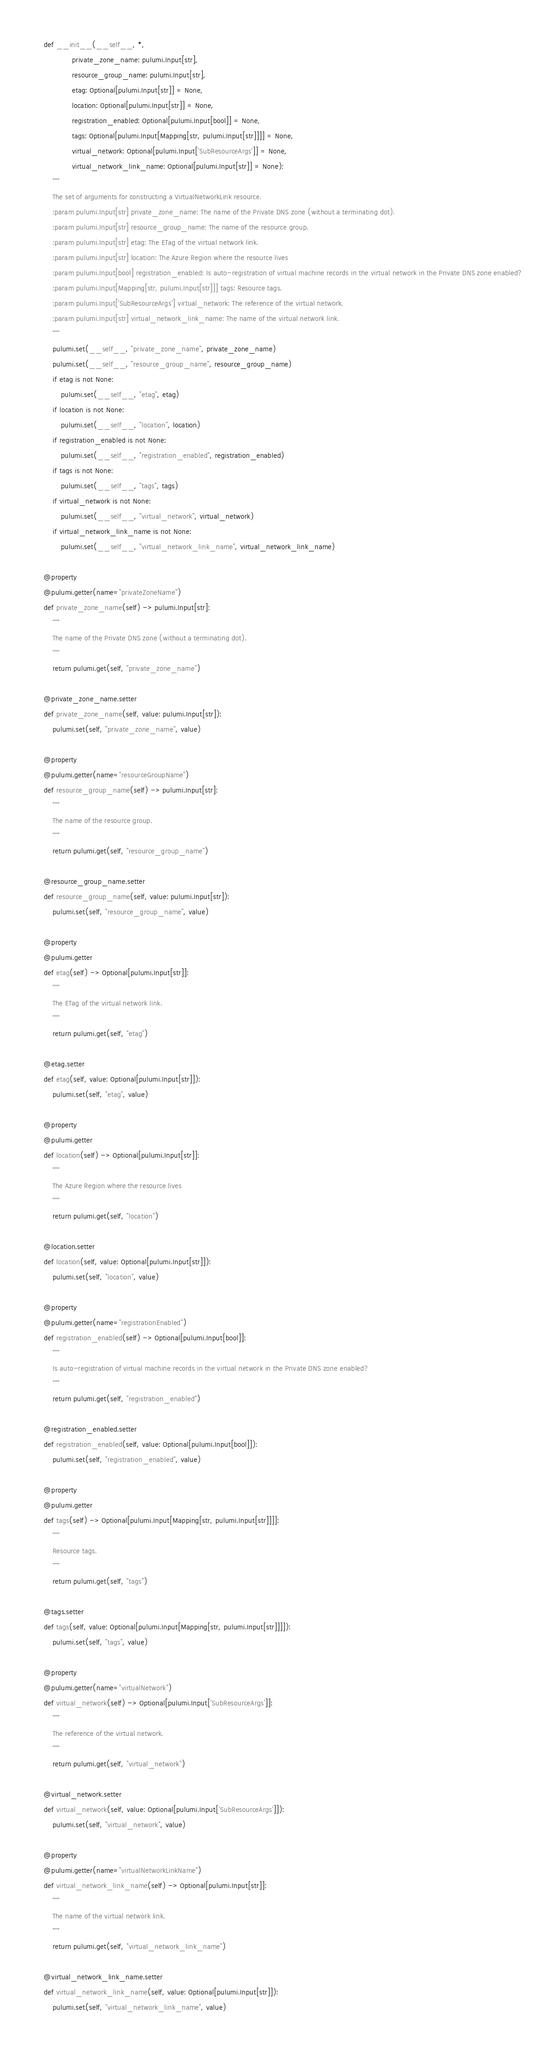Convert code to text. <code><loc_0><loc_0><loc_500><loc_500><_Python_>    def __init__(__self__, *,
                 private_zone_name: pulumi.Input[str],
                 resource_group_name: pulumi.Input[str],
                 etag: Optional[pulumi.Input[str]] = None,
                 location: Optional[pulumi.Input[str]] = None,
                 registration_enabled: Optional[pulumi.Input[bool]] = None,
                 tags: Optional[pulumi.Input[Mapping[str, pulumi.Input[str]]]] = None,
                 virtual_network: Optional[pulumi.Input['SubResourceArgs']] = None,
                 virtual_network_link_name: Optional[pulumi.Input[str]] = None):
        """
        The set of arguments for constructing a VirtualNetworkLink resource.
        :param pulumi.Input[str] private_zone_name: The name of the Private DNS zone (without a terminating dot).
        :param pulumi.Input[str] resource_group_name: The name of the resource group.
        :param pulumi.Input[str] etag: The ETag of the virtual network link.
        :param pulumi.Input[str] location: The Azure Region where the resource lives
        :param pulumi.Input[bool] registration_enabled: Is auto-registration of virtual machine records in the virtual network in the Private DNS zone enabled?
        :param pulumi.Input[Mapping[str, pulumi.Input[str]]] tags: Resource tags.
        :param pulumi.Input['SubResourceArgs'] virtual_network: The reference of the virtual network.
        :param pulumi.Input[str] virtual_network_link_name: The name of the virtual network link.
        """
        pulumi.set(__self__, "private_zone_name", private_zone_name)
        pulumi.set(__self__, "resource_group_name", resource_group_name)
        if etag is not None:
            pulumi.set(__self__, "etag", etag)
        if location is not None:
            pulumi.set(__self__, "location", location)
        if registration_enabled is not None:
            pulumi.set(__self__, "registration_enabled", registration_enabled)
        if tags is not None:
            pulumi.set(__self__, "tags", tags)
        if virtual_network is not None:
            pulumi.set(__self__, "virtual_network", virtual_network)
        if virtual_network_link_name is not None:
            pulumi.set(__self__, "virtual_network_link_name", virtual_network_link_name)

    @property
    @pulumi.getter(name="privateZoneName")
    def private_zone_name(self) -> pulumi.Input[str]:
        """
        The name of the Private DNS zone (without a terminating dot).
        """
        return pulumi.get(self, "private_zone_name")

    @private_zone_name.setter
    def private_zone_name(self, value: pulumi.Input[str]):
        pulumi.set(self, "private_zone_name", value)

    @property
    @pulumi.getter(name="resourceGroupName")
    def resource_group_name(self) -> pulumi.Input[str]:
        """
        The name of the resource group.
        """
        return pulumi.get(self, "resource_group_name")

    @resource_group_name.setter
    def resource_group_name(self, value: pulumi.Input[str]):
        pulumi.set(self, "resource_group_name", value)

    @property
    @pulumi.getter
    def etag(self) -> Optional[pulumi.Input[str]]:
        """
        The ETag of the virtual network link.
        """
        return pulumi.get(self, "etag")

    @etag.setter
    def etag(self, value: Optional[pulumi.Input[str]]):
        pulumi.set(self, "etag", value)

    @property
    @pulumi.getter
    def location(self) -> Optional[pulumi.Input[str]]:
        """
        The Azure Region where the resource lives
        """
        return pulumi.get(self, "location")

    @location.setter
    def location(self, value: Optional[pulumi.Input[str]]):
        pulumi.set(self, "location", value)

    @property
    @pulumi.getter(name="registrationEnabled")
    def registration_enabled(self) -> Optional[pulumi.Input[bool]]:
        """
        Is auto-registration of virtual machine records in the virtual network in the Private DNS zone enabled?
        """
        return pulumi.get(self, "registration_enabled")

    @registration_enabled.setter
    def registration_enabled(self, value: Optional[pulumi.Input[bool]]):
        pulumi.set(self, "registration_enabled", value)

    @property
    @pulumi.getter
    def tags(self) -> Optional[pulumi.Input[Mapping[str, pulumi.Input[str]]]]:
        """
        Resource tags.
        """
        return pulumi.get(self, "tags")

    @tags.setter
    def tags(self, value: Optional[pulumi.Input[Mapping[str, pulumi.Input[str]]]]):
        pulumi.set(self, "tags", value)

    @property
    @pulumi.getter(name="virtualNetwork")
    def virtual_network(self) -> Optional[pulumi.Input['SubResourceArgs']]:
        """
        The reference of the virtual network.
        """
        return pulumi.get(self, "virtual_network")

    @virtual_network.setter
    def virtual_network(self, value: Optional[pulumi.Input['SubResourceArgs']]):
        pulumi.set(self, "virtual_network", value)

    @property
    @pulumi.getter(name="virtualNetworkLinkName")
    def virtual_network_link_name(self) -> Optional[pulumi.Input[str]]:
        """
        The name of the virtual network link.
        """
        return pulumi.get(self, "virtual_network_link_name")

    @virtual_network_link_name.setter
    def virtual_network_link_name(self, value: Optional[pulumi.Input[str]]):
        pulumi.set(self, "virtual_network_link_name", value)

</code> 